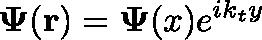<formula> <loc_0><loc_0><loc_500><loc_500>\Psi ( r ) = \Psi ( x ) e ^ { i k _ { t } y }</formula> 